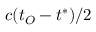Convert formula to latex. <formula><loc_0><loc_0><loc_500><loc_500>c ( t _ { O } - t ^ { * } ) / 2</formula> 